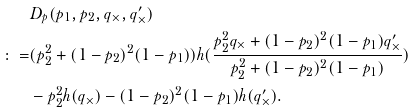Convert formula to latex. <formula><loc_0><loc_0><loc_500><loc_500>& D _ { p } ( p _ { 1 } , p _ { 2 } , q _ { \times } , q _ { \times } ^ { \prime } ) \\ \colon = & ( p _ { 2 } ^ { 2 } + ( 1 - p _ { 2 } ) ^ { 2 } ( 1 - p _ { 1 } ) ) h ( \frac { p _ { 2 } ^ { 2 } q _ { \times } + ( 1 - p _ { 2 } ) ^ { 2 } ( 1 - p _ { 1 } ) q _ { \times } ^ { \prime } } { p _ { 2 } ^ { 2 } + ( 1 - p _ { 2 } ) ^ { 2 } ( 1 - p _ { 1 } ) } ) \\ & - p _ { 2 } ^ { 2 } h ( q _ { \times } ) - ( 1 - p _ { 2 } ) ^ { 2 } ( 1 - p _ { 1 } ) h ( q _ { \times } ^ { \prime } ) .</formula> 